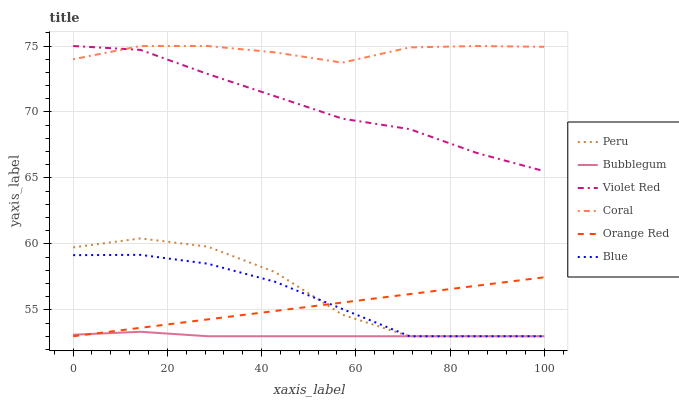Does Bubblegum have the minimum area under the curve?
Answer yes or no. Yes. Does Violet Red have the minimum area under the curve?
Answer yes or no. No. Does Violet Red have the maximum area under the curve?
Answer yes or no. No. Is Orange Red the smoothest?
Answer yes or no. Yes. Is Peru the roughest?
Answer yes or no. Yes. Is Violet Red the smoothest?
Answer yes or no. No. Is Violet Red the roughest?
Answer yes or no. No. Does Violet Red have the lowest value?
Answer yes or no. No. Does Bubblegum have the highest value?
Answer yes or no. No. Is Bubblegum less than Violet Red?
Answer yes or no. Yes. Is Coral greater than Blue?
Answer yes or no. Yes. Does Bubblegum intersect Violet Red?
Answer yes or no. No. 